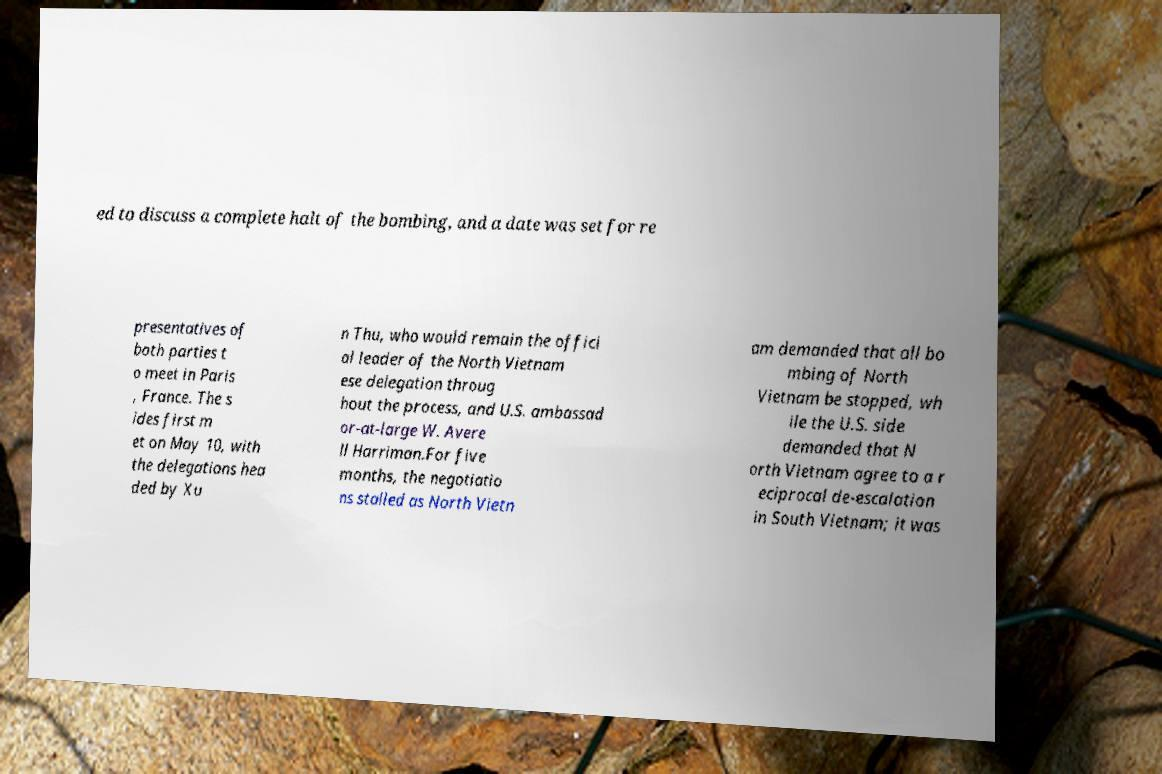Please identify and transcribe the text found in this image. ed to discuss a complete halt of the bombing, and a date was set for re presentatives of both parties t o meet in Paris , France. The s ides first m et on May 10, with the delegations hea ded by Xu n Thu, who would remain the offici al leader of the North Vietnam ese delegation throug hout the process, and U.S. ambassad or-at-large W. Avere ll Harriman.For five months, the negotiatio ns stalled as North Vietn am demanded that all bo mbing of North Vietnam be stopped, wh ile the U.S. side demanded that N orth Vietnam agree to a r eciprocal de-escalation in South Vietnam; it was 